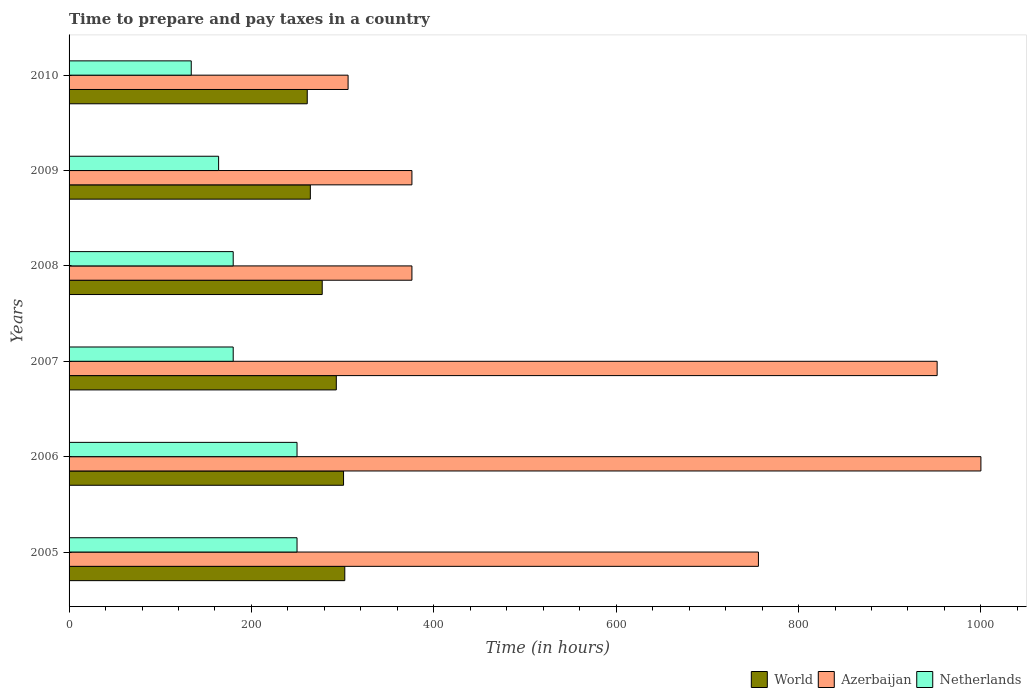Are the number of bars on each tick of the Y-axis equal?
Give a very brief answer. Yes. How many bars are there on the 2nd tick from the bottom?
Keep it short and to the point. 3. What is the label of the 1st group of bars from the top?
Your response must be concise. 2010. What is the number of hours required to prepare and pay taxes in Netherlands in 2005?
Provide a succinct answer. 250. Across all years, what is the maximum number of hours required to prepare and pay taxes in World?
Give a very brief answer. 302.39. Across all years, what is the minimum number of hours required to prepare and pay taxes in Azerbaijan?
Give a very brief answer. 306. In which year was the number of hours required to prepare and pay taxes in World maximum?
Keep it short and to the point. 2005. In which year was the number of hours required to prepare and pay taxes in Azerbaijan minimum?
Make the answer very short. 2010. What is the total number of hours required to prepare and pay taxes in World in the graph?
Offer a very short reply. 1699.92. What is the difference between the number of hours required to prepare and pay taxes in Azerbaijan in 2005 and that in 2010?
Keep it short and to the point. 450. What is the difference between the number of hours required to prepare and pay taxes in World in 2008 and the number of hours required to prepare and pay taxes in Netherlands in 2007?
Provide a short and direct response. 97.63. What is the average number of hours required to prepare and pay taxes in Netherlands per year?
Your answer should be very brief. 193. In the year 2007, what is the difference between the number of hours required to prepare and pay taxes in World and number of hours required to prepare and pay taxes in Azerbaijan?
Your response must be concise. -658.92. What is the ratio of the number of hours required to prepare and pay taxes in Azerbaijan in 2006 to that in 2007?
Your response must be concise. 1.05. Is the difference between the number of hours required to prepare and pay taxes in World in 2007 and 2008 greater than the difference between the number of hours required to prepare and pay taxes in Azerbaijan in 2007 and 2008?
Your answer should be very brief. No. What is the difference between the highest and the second highest number of hours required to prepare and pay taxes in World?
Provide a short and direct response. 1.38. What is the difference between the highest and the lowest number of hours required to prepare and pay taxes in Netherlands?
Your answer should be very brief. 116. In how many years, is the number of hours required to prepare and pay taxes in World greater than the average number of hours required to prepare and pay taxes in World taken over all years?
Offer a very short reply. 3. Is the sum of the number of hours required to prepare and pay taxes in Netherlands in 2007 and 2009 greater than the maximum number of hours required to prepare and pay taxes in World across all years?
Make the answer very short. Yes. What does the 2nd bar from the bottom in 2009 represents?
Your answer should be very brief. Azerbaijan. Is it the case that in every year, the sum of the number of hours required to prepare and pay taxes in World and number of hours required to prepare and pay taxes in Azerbaijan is greater than the number of hours required to prepare and pay taxes in Netherlands?
Offer a terse response. Yes. How many years are there in the graph?
Offer a very short reply. 6. Are the values on the major ticks of X-axis written in scientific E-notation?
Ensure brevity in your answer.  No. Does the graph contain any zero values?
Ensure brevity in your answer.  No. Does the graph contain grids?
Keep it short and to the point. No. Where does the legend appear in the graph?
Give a very brief answer. Bottom right. How many legend labels are there?
Make the answer very short. 3. How are the legend labels stacked?
Your response must be concise. Horizontal. What is the title of the graph?
Your answer should be compact. Time to prepare and pay taxes in a country. Does "Pacific island small states" appear as one of the legend labels in the graph?
Offer a terse response. No. What is the label or title of the X-axis?
Your answer should be very brief. Time (in hours). What is the label or title of the Y-axis?
Keep it short and to the point. Years. What is the Time (in hours) of World in 2005?
Ensure brevity in your answer.  302.39. What is the Time (in hours) of Azerbaijan in 2005?
Ensure brevity in your answer.  756. What is the Time (in hours) of Netherlands in 2005?
Give a very brief answer. 250. What is the Time (in hours) in World in 2006?
Your answer should be very brief. 301.01. What is the Time (in hours) in Azerbaijan in 2006?
Keep it short and to the point. 1000. What is the Time (in hours) of Netherlands in 2006?
Give a very brief answer. 250. What is the Time (in hours) in World in 2007?
Your answer should be very brief. 293.08. What is the Time (in hours) in Azerbaijan in 2007?
Offer a terse response. 952. What is the Time (in hours) in Netherlands in 2007?
Ensure brevity in your answer.  180. What is the Time (in hours) of World in 2008?
Offer a very short reply. 277.63. What is the Time (in hours) in Azerbaijan in 2008?
Make the answer very short. 376. What is the Time (in hours) of Netherlands in 2008?
Provide a short and direct response. 180. What is the Time (in hours) of World in 2009?
Offer a terse response. 264.6. What is the Time (in hours) of Azerbaijan in 2009?
Ensure brevity in your answer.  376. What is the Time (in hours) of Netherlands in 2009?
Your response must be concise. 164. What is the Time (in hours) of World in 2010?
Your response must be concise. 261.21. What is the Time (in hours) of Azerbaijan in 2010?
Ensure brevity in your answer.  306. What is the Time (in hours) in Netherlands in 2010?
Your answer should be compact. 134. Across all years, what is the maximum Time (in hours) in World?
Your answer should be compact. 302.39. Across all years, what is the maximum Time (in hours) of Netherlands?
Offer a very short reply. 250. Across all years, what is the minimum Time (in hours) of World?
Your answer should be compact. 261.21. Across all years, what is the minimum Time (in hours) of Azerbaijan?
Your response must be concise. 306. Across all years, what is the minimum Time (in hours) in Netherlands?
Keep it short and to the point. 134. What is the total Time (in hours) of World in the graph?
Give a very brief answer. 1699.92. What is the total Time (in hours) of Azerbaijan in the graph?
Provide a short and direct response. 3766. What is the total Time (in hours) in Netherlands in the graph?
Your answer should be compact. 1158. What is the difference between the Time (in hours) of World in 2005 and that in 2006?
Offer a terse response. 1.38. What is the difference between the Time (in hours) of Azerbaijan in 2005 and that in 2006?
Provide a short and direct response. -244. What is the difference between the Time (in hours) in World in 2005 and that in 2007?
Ensure brevity in your answer.  9.32. What is the difference between the Time (in hours) of Azerbaijan in 2005 and that in 2007?
Provide a succinct answer. -196. What is the difference between the Time (in hours) of Netherlands in 2005 and that in 2007?
Offer a very short reply. 70. What is the difference between the Time (in hours) of World in 2005 and that in 2008?
Provide a short and direct response. 24.77. What is the difference between the Time (in hours) of Azerbaijan in 2005 and that in 2008?
Provide a succinct answer. 380. What is the difference between the Time (in hours) in World in 2005 and that in 2009?
Offer a terse response. 37.79. What is the difference between the Time (in hours) in Azerbaijan in 2005 and that in 2009?
Your answer should be very brief. 380. What is the difference between the Time (in hours) of World in 2005 and that in 2010?
Make the answer very short. 41.18. What is the difference between the Time (in hours) in Azerbaijan in 2005 and that in 2010?
Your answer should be compact. 450. What is the difference between the Time (in hours) of Netherlands in 2005 and that in 2010?
Keep it short and to the point. 116. What is the difference between the Time (in hours) of World in 2006 and that in 2007?
Make the answer very short. 7.93. What is the difference between the Time (in hours) in Netherlands in 2006 and that in 2007?
Provide a succinct answer. 70. What is the difference between the Time (in hours) in World in 2006 and that in 2008?
Give a very brief answer. 23.38. What is the difference between the Time (in hours) of Azerbaijan in 2006 and that in 2008?
Provide a short and direct response. 624. What is the difference between the Time (in hours) of Netherlands in 2006 and that in 2008?
Your response must be concise. 70. What is the difference between the Time (in hours) in World in 2006 and that in 2009?
Ensure brevity in your answer.  36.4. What is the difference between the Time (in hours) of Azerbaijan in 2006 and that in 2009?
Provide a short and direct response. 624. What is the difference between the Time (in hours) in World in 2006 and that in 2010?
Provide a short and direct response. 39.8. What is the difference between the Time (in hours) in Azerbaijan in 2006 and that in 2010?
Your answer should be compact. 694. What is the difference between the Time (in hours) in Netherlands in 2006 and that in 2010?
Your response must be concise. 116. What is the difference between the Time (in hours) in World in 2007 and that in 2008?
Ensure brevity in your answer.  15.45. What is the difference between the Time (in hours) in Azerbaijan in 2007 and that in 2008?
Provide a short and direct response. 576. What is the difference between the Time (in hours) in Netherlands in 2007 and that in 2008?
Your answer should be compact. 0. What is the difference between the Time (in hours) in World in 2007 and that in 2009?
Your answer should be compact. 28.47. What is the difference between the Time (in hours) of Azerbaijan in 2007 and that in 2009?
Provide a succinct answer. 576. What is the difference between the Time (in hours) in Netherlands in 2007 and that in 2009?
Keep it short and to the point. 16. What is the difference between the Time (in hours) of World in 2007 and that in 2010?
Provide a short and direct response. 31.87. What is the difference between the Time (in hours) in Azerbaijan in 2007 and that in 2010?
Ensure brevity in your answer.  646. What is the difference between the Time (in hours) in World in 2008 and that in 2009?
Provide a short and direct response. 13.02. What is the difference between the Time (in hours) of Netherlands in 2008 and that in 2009?
Offer a terse response. 16. What is the difference between the Time (in hours) of World in 2008 and that in 2010?
Your answer should be very brief. 16.42. What is the difference between the Time (in hours) in Netherlands in 2008 and that in 2010?
Provide a succinct answer. 46. What is the difference between the Time (in hours) of World in 2009 and that in 2010?
Your answer should be compact. 3.4. What is the difference between the Time (in hours) in Netherlands in 2009 and that in 2010?
Ensure brevity in your answer.  30. What is the difference between the Time (in hours) in World in 2005 and the Time (in hours) in Azerbaijan in 2006?
Provide a short and direct response. -697.61. What is the difference between the Time (in hours) of World in 2005 and the Time (in hours) of Netherlands in 2006?
Make the answer very short. 52.39. What is the difference between the Time (in hours) of Azerbaijan in 2005 and the Time (in hours) of Netherlands in 2006?
Ensure brevity in your answer.  506. What is the difference between the Time (in hours) in World in 2005 and the Time (in hours) in Azerbaijan in 2007?
Give a very brief answer. -649.61. What is the difference between the Time (in hours) in World in 2005 and the Time (in hours) in Netherlands in 2007?
Offer a very short reply. 122.39. What is the difference between the Time (in hours) in Azerbaijan in 2005 and the Time (in hours) in Netherlands in 2007?
Your response must be concise. 576. What is the difference between the Time (in hours) of World in 2005 and the Time (in hours) of Azerbaijan in 2008?
Provide a short and direct response. -73.61. What is the difference between the Time (in hours) of World in 2005 and the Time (in hours) of Netherlands in 2008?
Provide a succinct answer. 122.39. What is the difference between the Time (in hours) of Azerbaijan in 2005 and the Time (in hours) of Netherlands in 2008?
Provide a succinct answer. 576. What is the difference between the Time (in hours) in World in 2005 and the Time (in hours) in Azerbaijan in 2009?
Ensure brevity in your answer.  -73.61. What is the difference between the Time (in hours) in World in 2005 and the Time (in hours) in Netherlands in 2009?
Provide a succinct answer. 138.39. What is the difference between the Time (in hours) in Azerbaijan in 2005 and the Time (in hours) in Netherlands in 2009?
Ensure brevity in your answer.  592. What is the difference between the Time (in hours) of World in 2005 and the Time (in hours) of Azerbaijan in 2010?
Offer a very short reply. -3.61. What is the difference between the Time (in hours) of World in 2005 and the Time (in hours) of Netherlands in 2010?
Your answer should be compact. 168.39. What is the difference between the Time (in hours) in Azerbaijan in 2005 and the Time (in hours) in Netherlands in 2010?
Offer a terse response. 622. What is the difference between the Time (in hours) of World in 2006 and the Time (in hours) of Azerbaijan in 2007?
Offer a terse response. -650.99. What is the difference between the Time (in hours) in World in 2006 and the Time (in hours) in Netherlands in 2007?
Offer a very short reply. 121.01. What is the difference between the Time (in hours) in Azerbaijan in 2006 and the Time (in hours) in Netherlands in 2007?
Give a very brief answer. 820. What is the difference between the Time (in hours) in World in 2006 and the Time (in hours) in Azerbaijan in 2008?
Make the answer very short. -74.99. What is the difference between the Time (in hours) in World in 2006 and the Time (in hours) in Netherlands in 2008?
Offer a terse response. 121.01. What is the difference between the Time (in hours) of Azerbaijan in 2006 and the Time (in hours) of Netherlands in 2008?
Your answer should be compact. 820. What is the difference between the Time (in hours) in World in 2006 and the Time (in hours) in Azerbaijan in 2009?
Your answer should be compact. -74.99. What is the difference between the Time (in hours) of World in 2006 and the Time (in hours) of Netherlands in 2009?
Your response must be concise. 137.01. What is the difference between the Time (in hours) in Azerbaijan in 2006 and the Time (in hours) in Netherlands in 2009?
Your response must be concise. 836. What is the difference between the Time (in hours) of World in 2006 and the Time (in hours) of Azerbaijan in 2010?
Offer a terse response. -4.99. What is the difference between the Time (in hours) of World in 2006 and the Time (in hours) of Netherlands in 2010?
Your answer should be very brief. 167.01. What is the difference between the Time (in hours) in Azerbaijan in 2006 and the Time (in hours) in Netherlands in 2010?
Your response must be concise. 866. What is the difference between the Time (in hours) of World in 2007 and the Time (in hours) of Azerbaijan in 2008?
Give a very brief answer. -82.92. What is the difference between the Time (in hours) of World in 2007 and the Time (in hours) of Netherlands in 2008?
Give a very brief answer. 113.08. What is the difference between the Time (in hours) of Azerbaijan in 2007 and the Time (in hours) of Netherlands in 2008?
Your answer should be compact. 772. What is the difference between the Time (in hours) of World in 2007 and the Time (in hours) of Azerbaijan in 2009?
Your answer should be very brief. -82.92. What is the difference between the Time (in hours) of World in 2007 and the Time (in hours) of Netherlands in 2009?
Provide a short and direct response. 129.08. What is the difference between the Time (in hours) of Azerbaijan in 2007 and the Time (in hours) of Netherlands in 2009?
Give a very brief answer. 788. What is the difference between the Time (in hours) in World in 2007 and the Time (in hours) in Azerbaijan in 2010?
Your answer should be very brief. -12.92. What is the difference between the Time (in hours) of World in 2007 and the Time (in hours) of Netherlands in 2010?
Provide a short and direct response. 159.08. What is the difference between the Time (in hours) of Azerbaijan in 2007 and the Time (in hours) of Netherlands in 2010?
Give a very brief answer. 818. What is the difference between the Time (in hours) in World in 2008 and the Time (in hours) in Azerbaijan in 2009?
Give a very brief answer. -98.37. What is the difference between the Time (in hours) in World in 2008 and the Time (in hours) in Netherlands in 2009?
Provide a short and direct response. 113.63. What is the difference between the Time (in hours) in Azerbaijan in 2008 and the Time (in hours) in Netherlands in 2009?
Your answer should be very brief. 212. What is the difference between the Time (in hours) of World in 2008 and the Time (in hours) of Azerbaijan in 2010?
Give a very brief answer. -28.37. What is the difference between the Time (in hours) in World in 2008 and the Time (in hours) in Netherlands in 2010?
Give a very brief answer. 143.63. What is the difference between the Time (in hours) in Azerbaijan in 2008 and the Time (in hours) in Netherlands in 2010?
Offer a terse response. 242. What is the difference between the Time (in hours) in World in 2009 and the Time (in hours) in Azerbaijan in 2010?
Keep it short and to the point. -41.4. What is the difference between the Time (in hours) of World in 2009 and the Time (in hours) of Netherlands in 2010?
Your answer should be compact. 130.6. What is the difference between the Time (in hours) in Azerbaijan in 2009 and the Time (in hours) in Netherlands in 2010?
Provide a short and direct response. 242. What is the average Time (in hours) of World per year?
Ensure brevity in your answer.  283.32. What is the average Time (in hours) of Azerbaijan per year?
Your answer should be very brief. 627.67. What is the average Time (in hours) in Netherlands per year?
Provide a succinct answer. 193. In the year 2005, what is the difference between the Time (in hours) in World and Time (in hours) in Azerbaijan?
Offer a terse response. -453.61. In the year 2005, what is the difference between the Time (in hours) in World and Time (in hours) in Netherlands?
Give a very brief answer. 52.39. In the year 2005, what is the difference between the Time (in hours) in Azerbaijan and Time (in hours) in Netherlands?
Give a very brief answer. 506. In the year 2006, what is the difference between the Time (in hours) in World and Time (in hours) in Azerbaijan?
Provide a short and direct response. -698.99. In the year 2006, what is the difference between the Time (in hours) of World and Time (in hours) of Netherlands?
Make the answer very short. 51.01. In the year 2006, what is the difference between the Time (in hours) in Azerbaijan and Time (in hours) in Netherlands?
Provide a short and direct response. 750. In the year 2007, what is the difference between the Time (in hours) of World and Time (in hours) of Azerbaijan?
Give a very brief answer. -658.92. In the year 2007, what is the difference between the Time (in hours) in World and Time (in hours) in Netherlands?
Provide a short and direct response. 113.08. In the year 2007, what is the difference between the Time (in hours) of Azerbaijan and Time (in hours) of Netherlands?
Ensure brevity in your answer.  772. In the year 2008, what is the difference between the Time (in hours) of World and Time (in hours) of Azerbaijan?
Your answer should be very brief. -98.37. In the year 2008, what is the difference between the Time (in hours) in World and Time (in hours) in Netherlands?
Your answer should be compact. 97.63. In the year 2008, what is the difference between the Time (in hours) in Azerbaijan and Time (in hours) in Netherlands?
Give a very brief answer. 196. In the year 2009, what is the difference between the Time (in hours) of World and Time (in hours) of Azerbaijan?
Your answer should be compact. -111.4. In the year 2009, what is the difference between the Time (in hours) of World and Time (in hours) of Netherlands?
Offer a very short reply. 100.6. In the year 2009, what is the difference between the Time (in hours) in Azerbaijan and Time (in hours) in Netherlands?
Your response must be concise. 212. In the year 2010, what is the difference between the Time (in hours) of World and Time (in hours) of Azerbaijan?
Give a very brief answer. -44.79. In the year 2010, what is the difference between the Time (in hours) in World and Time (in hours) in Netherlands?
Offer a terse response. 127.21. In the year 2010, what is the difference between the Time (in hours) of Azerbaijan and Time (in hours) of Netherlands?
Your answer should be compact. 172. What is the ratio of the Time (in hours) in Azerbaijan in 2005 to that in 2006?
Offer a very short reply. 0.76. What is the ratio of the Time (in hours) in World in 2005 to that in 2007?
Your answer should be compact. 1.03. What is the ratio of the Time (in hours) in Azerbaijan in 2005 to that in 2007?
Your answer should be compact. 0.79. What is the ratio of the Time (in hours) in Netherlands in 2005 to that in 2007?
Offer a terse response. 1.39. What is the ratio of the Time (in hours) of World in 2005 to that in 2008?
Keep it short and to the point. 1.09. What is the ratio of the Time (in hours) of Azerbaijan in 2005 to that in 2008?
Make the answer very short. 2.01. What is the ratio of the Time (in hours) in Netherlands in 2005 to that in 2008?
Offer a terse response. 1.39. What is the ratio of the Time (in hours) of World in 2005 to that in 2009?
Provide a succinct answer. 1.14. What is the ratio of the Time (in hours) in Azerbaijan in 2005 to that in 2009?
Your answer should be compact. 2.01. What is the ratio of the Time (in hours) in Netherlands in 2005 to that in 2009?
Give a very brief answer. 1.52. What is the ratio of the Time (in hours) of World in 2005 to that in 2010?
Make the answer very short. 1.16. What is the ratio of the Time (in hours) in Azerbaijan in 2005 to that in 2010?
Offer a terse response. 2.47. What is the ratio of the Time (in hours) of Netherlands in 2005 to that in 2010?
Provide a succinct answer. 1.87. What is the ratio of the Time (in hours) of World in 2006 to that in 2007?
Your answer should be compact. 1.03. What is the ratio of the Time (in hours) of Azerbaijan in 2006 to that in 2007?
Make the answer very short. 1.05. What is the ratio of the Time (in hours) in Netherlands in 2006 to that in 2007?
Provide a short and direct response. 1.39. What is the ratio of the Time (in hours) of World in 2006 to that in 2008?
Make the answer very short. 1.08. What is the ratio of the Time (in hours) in Azerbaijan in 2006 to that in 2008?
Your response must be concise. 2.66. What is the ratio of the Time (in hours) in Netherlands in 2006 to that in 2008?
Provide a short and direct response. 1.39. What is the ratio of the Time (in hours) of World in 2006 to that in 2009?
Provide a succinct answer. 1.14. What is the ratio of the Time (in hours) in Azerbaijan in 2006 to that in 2009?
Provide a short and direct response. 2.66. What is the ratio of the Time (in hours) in Netherlands in 2006 to that in 2009?
Your response must be concise. 1.52. What is the ratio of the Time (in hours) of World in 2006 to that in 2010?
Your response must be concise. 1.15. What is the ratio of the Time (in hours) of Azerbaijan in 2006 to that in 2010?
Offer a terse response. 3.27. What is the ratio of the Time (in hours) in Netherlands in 2006 to that in 2010?
Your response must be concise. 1.87. What is the ratio of the Time (in hours) of World in 2007 to that in 2008?
Keep it short and to the point. 1.06. What is the ratio of the Time (in hours) in Azerbaijan in 2007 to that in 2008?
Your response must be concise. 2.53. What is the ratio of the Time (in hours) of World in 2007 to that in 2009?
Keep it short and to the point. 1.11. What is the ratio of the Time (in hours) in Azerbaijan in 2007 to that in 2009?
Offer a terse response. 2.53. What is the ratio of the Time (in hours) in Netherlands in 2007 to that in 2009?
Your response must be concise. 1.1. What is the ratio of the Time (in hours) of World in 2007 to that in 2010?
Provide a short and direct response. 1.12. What is the ratio of the Time (in hours) of Azerbaijan in 2007 to that in 2010?
Your answer should be compact. 3.11. What is the ratio of the Time (in hours) in Netherlands in 2007 to that in 2010?
Ensure brevity in your answer.  1.34. What is the ratio of the Time (in hours) in World in 2008 to that in 2009?
Offer a terse response. 1.05. What is the ratio of the Time (in hours) of Azerbaijan in 2008 to that in 2009?
Keep it short and to the point. 1. What is the ratio of the Time (in hours) in Netherlands in 2008 to that in 2009?
Provide a succinct answer. 1.1. What is the ratio of the Time (in hours) of World in 2008 to that in 2010?
Your response must be concise. 1.06. What is the ratio of the Time (in hours) in Azerbaijan in 2008 to that in 2010?
Make the answer very short. 1.23. What is the ratio of the Time (in hours) in Netherlands in 2008 to that in 2010?
Your answer should be very brief. 1.34. What is the ratio of the Time (in hours) in Azerbaijan in 2009 to that in 2010?
Offer a terse response. 1.23. What is the ratio of the Time (in hours) of Netherlands in 2009 to that in 2010?
Ensure brevity in your answer.  1.22. What is the difference between the highest and the second highest Time (in hours) of World?
Your response must be concise. 1.38. What is the difference between the highest and the lowest Time (in hours) in World?
Your answer should be very brief. 41.18. What is the difference between the highest and the lowest Time (in hours) in Azerbaijan?
Make the answer very short. 694. What is the difference between the highest and the lowest Time (in hours) of Netherlands?
Your answer should be compact. 116. 